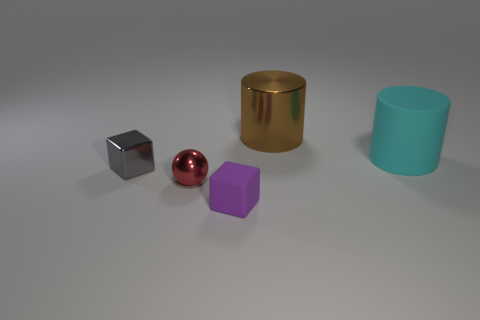How many other things are there of the same material as the cyan thing?
Keep it short and to the point. 1. There is a big cyan matte thing; does it have the same shape as the shiny object to the right of the purple matte block?
Make the answer very short. Yes. The brown object that is made of the same material as the red thing is what shape?
Make the answer very short. Cylinder. Are there more small gray metallic blocks that are behind the small gray shiny block than brown shiny cylinders that are right of the large matte cylinder?
Make the answer very short. No. What number of things are green shiny things or tiny gray objects?
Your answer should be compact. 1. What number of other objects are there of the same color as the matte cylinder?
Provide a succinct answer. 0. There is a matte object that is the same size as the red metallic object; what shape is it?
Ensure brevity in your answer.  Cube. There is a small block that is behind the small purple thing; what is its color?
Keep it short and to the point. Gray. What number of things are either metallic objects in front of the tiny gray metal block or tiny cubes that are behind the tiny red shiny sphere?
Provide a short and direct response. 2. Is the size of the brown metallic cylinder the same as the red thing?
Keep it short and to the point. No. 